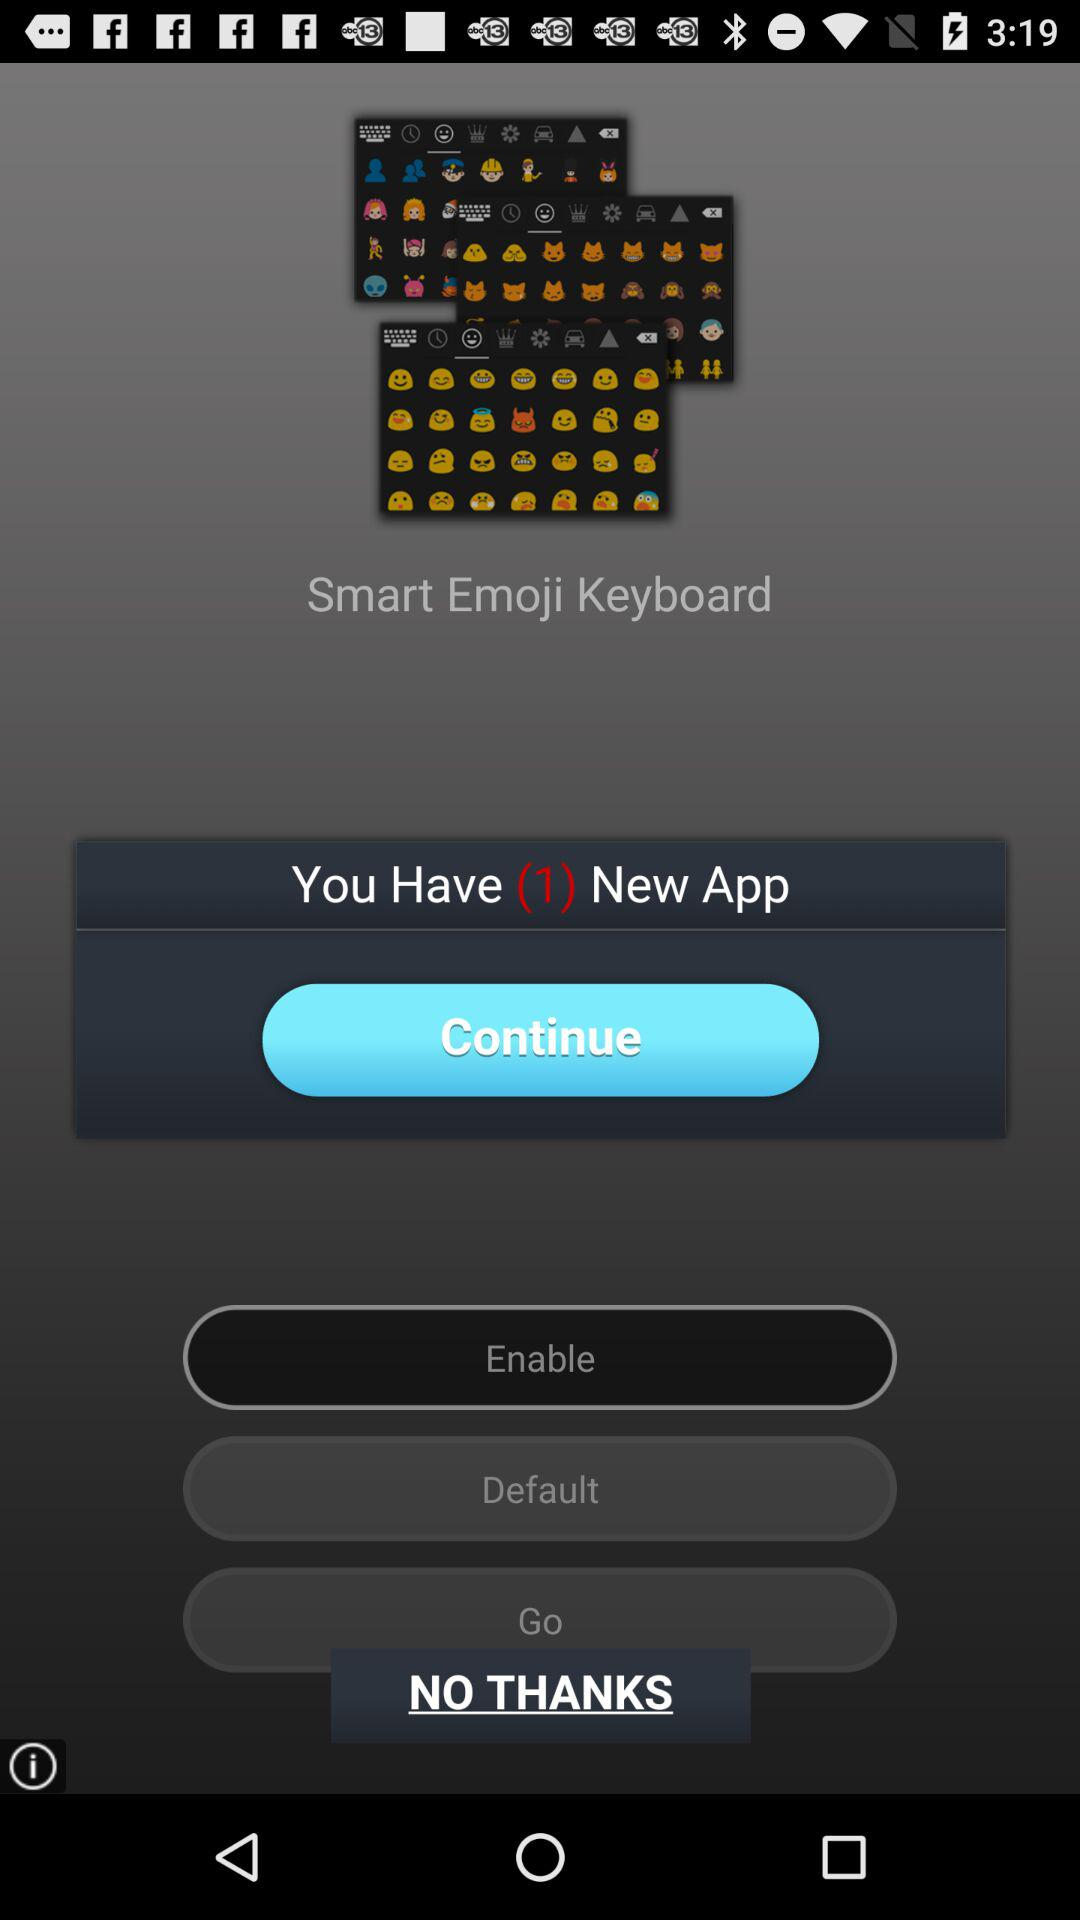What is the name of the application? The name of the application is "Smart Emoji Keyboard". 